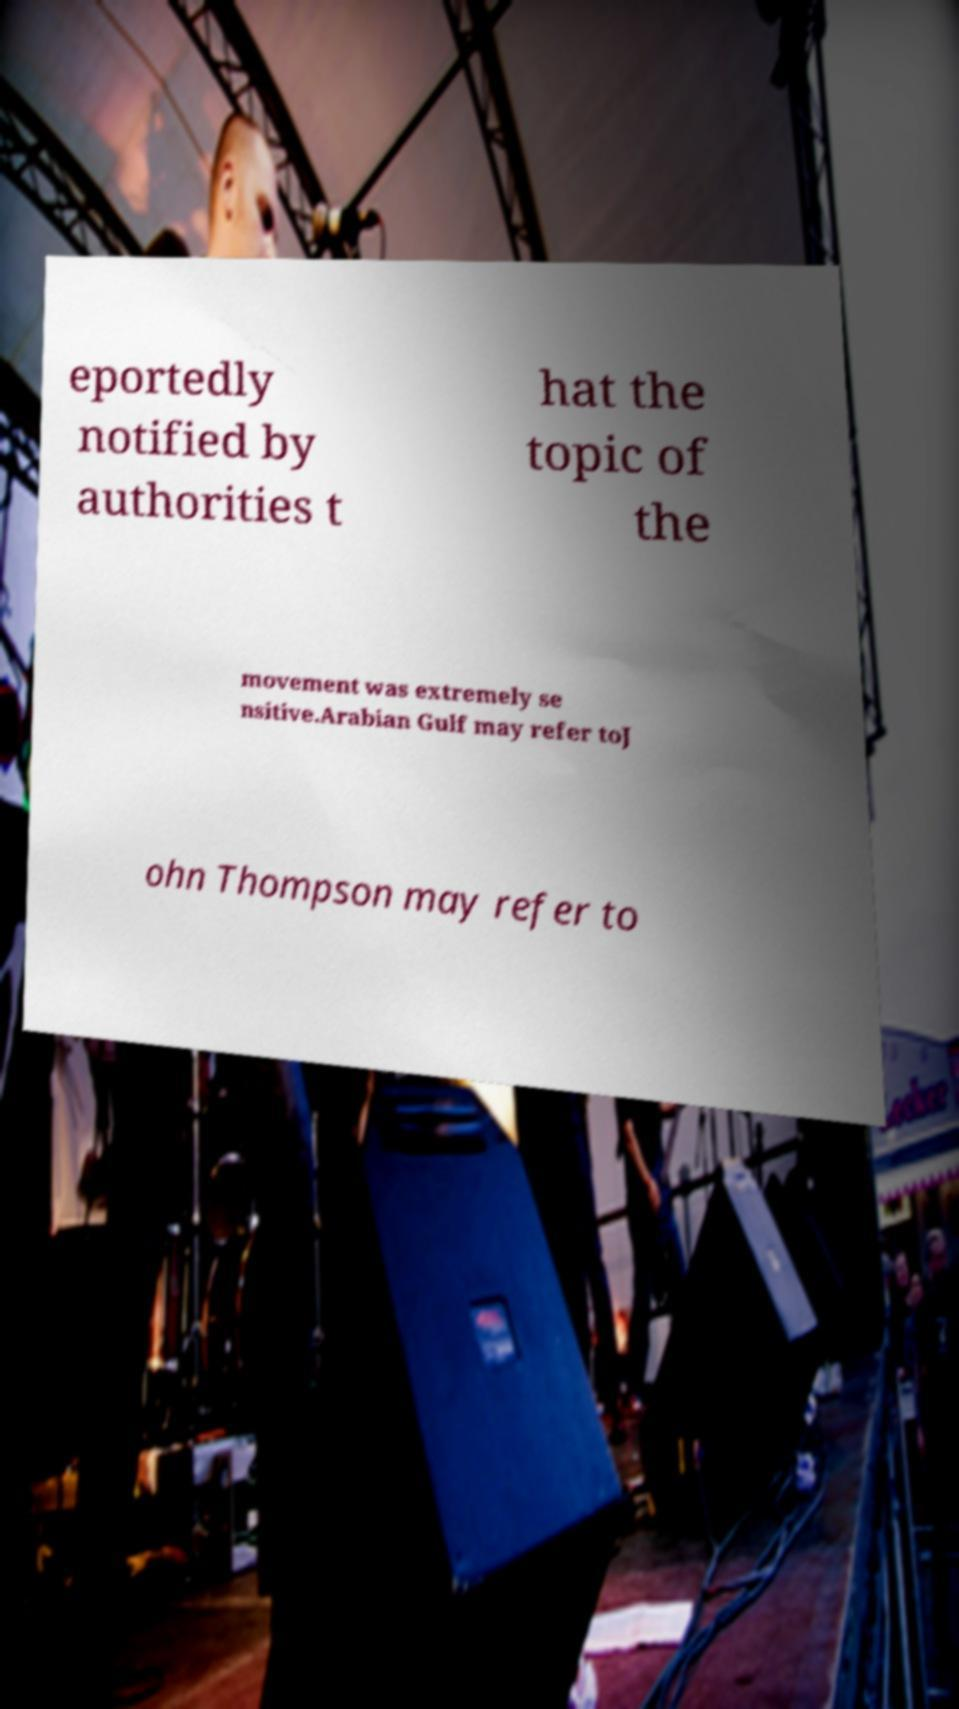I need the written content from this picture converted into text. Can you do that? eportedly notified by authorities t hat the topic of the movement was extremely se nsitive.Arabian Gulf may refer toJ ohn Thompson may refer to 